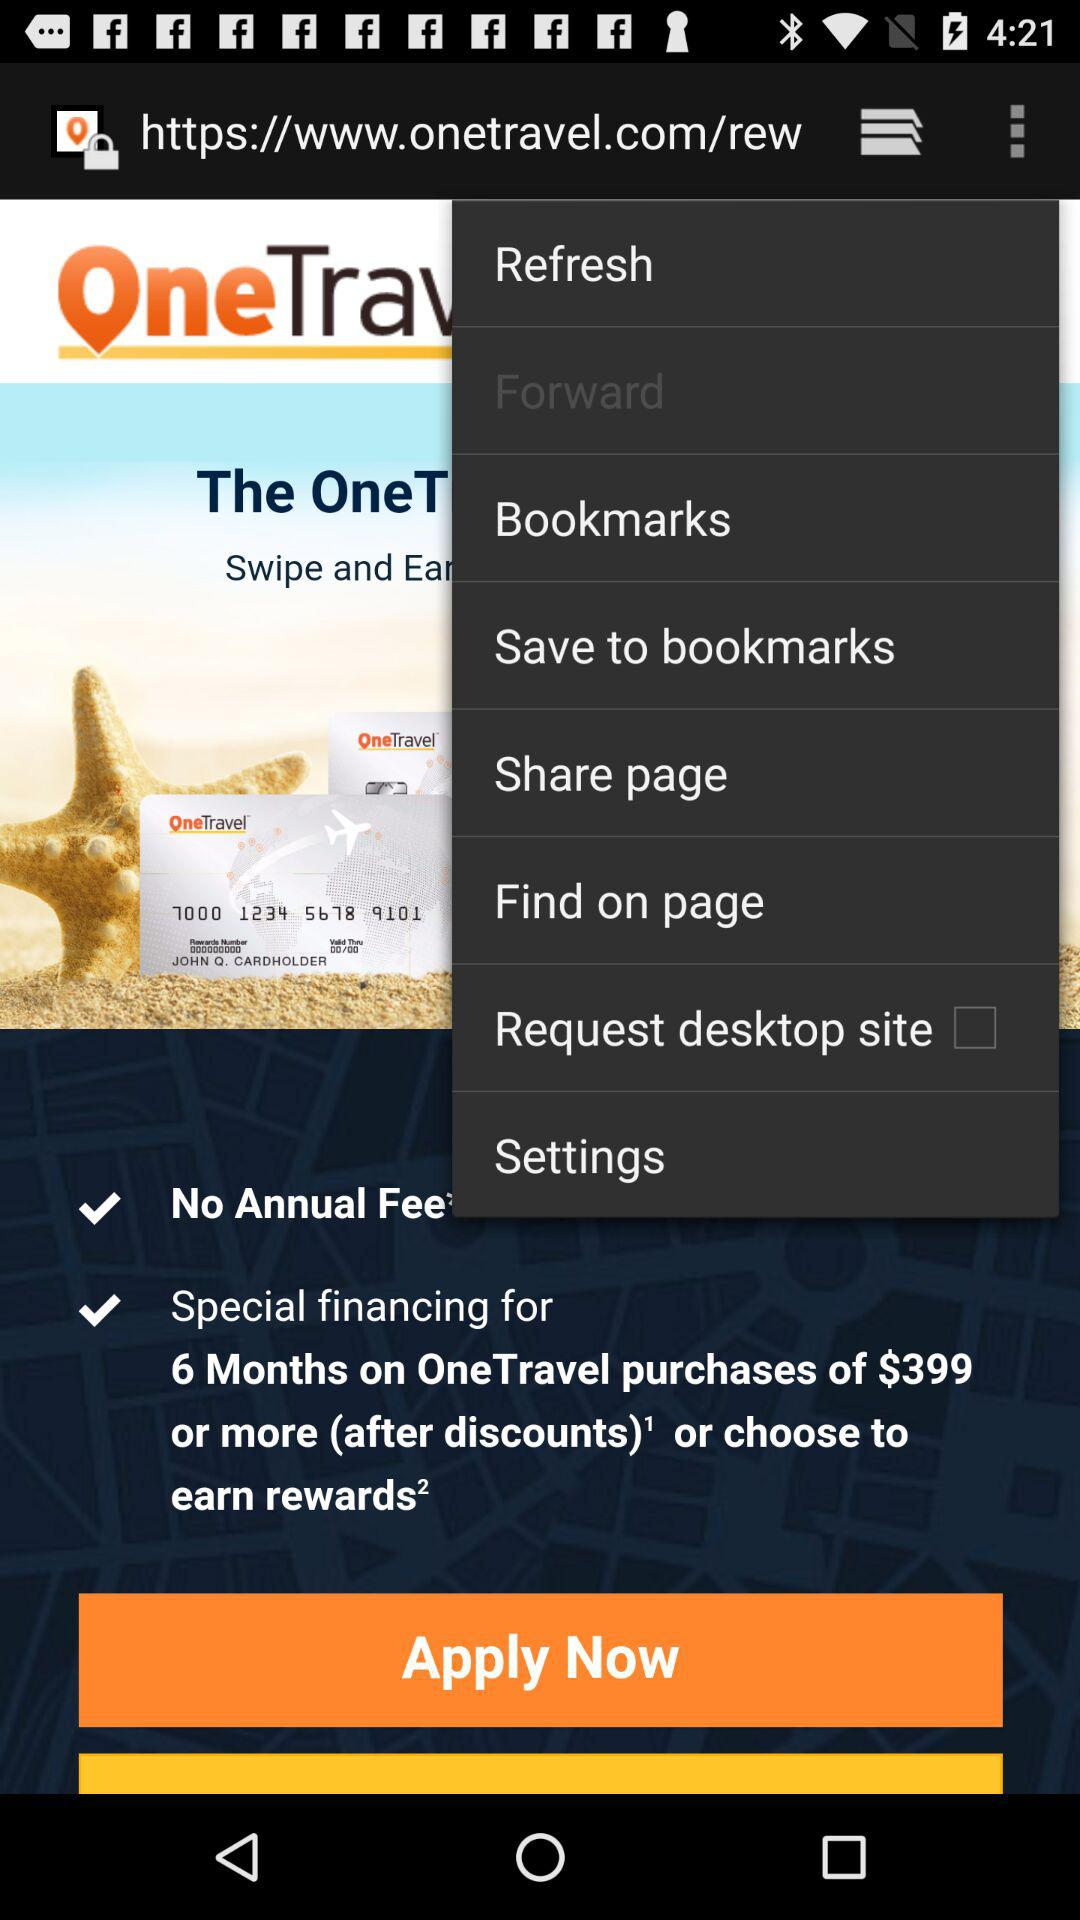What is the status of "Request desktop site"? The status is "off". 